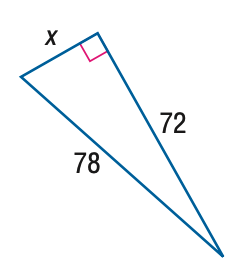Answer the mathemtical geometry problem and directly provide the correct option letter.
Question: Use a Pythagorean Triple to find x.
Choices: A: 26 B: 28 C: 30 D: 32 C 